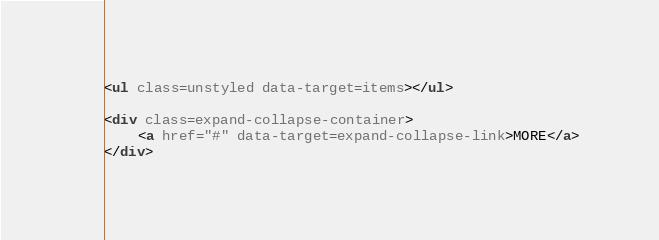Convert code to text. <code><loc_0><loc_0><loc_500><loc_500><_HTML_>
<ul class=unstyled data-target=items></ul>

<div class=expand-collapse-container>
    <a href="#" data-target=expand-collapse-link>MORE</a>
</div>
</code> 